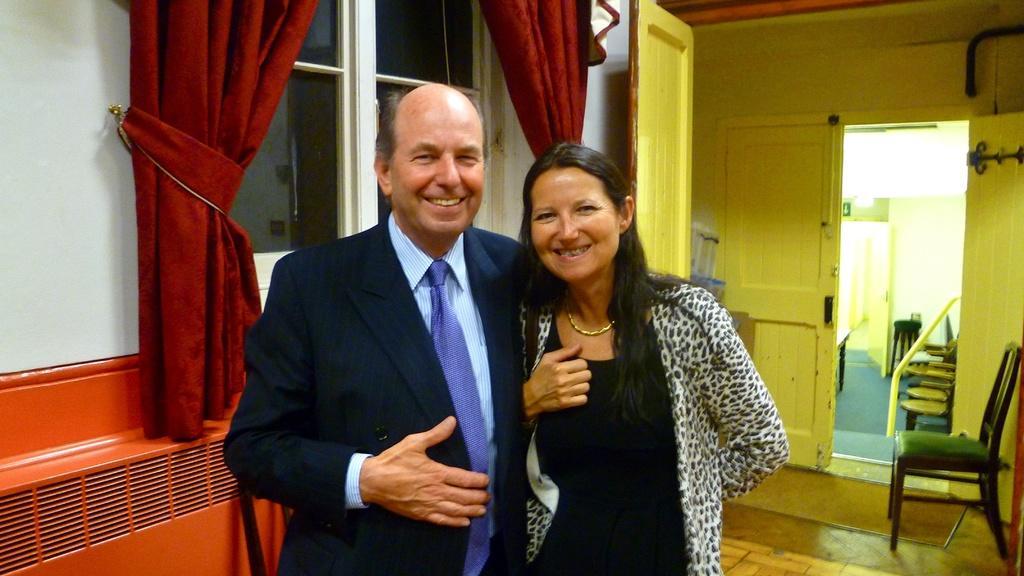How would you summarize this image in a sentence or two? In the center of the image there are two people standing. On the left there is a man standing and smiling. There is a lady next to him. In the background there is a door, chair, window, curtains and wall. 